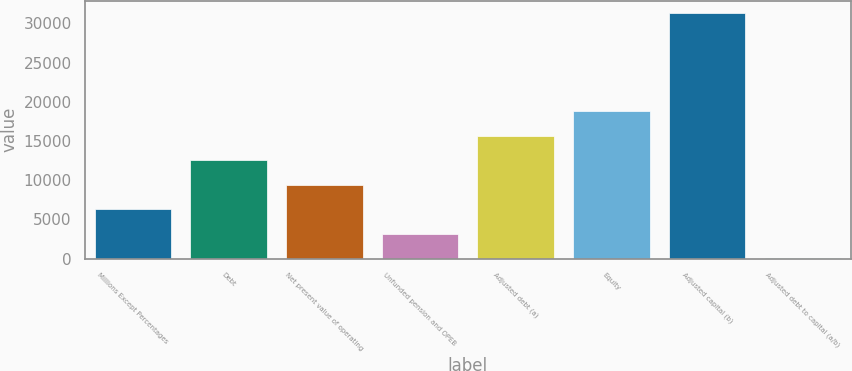<chart> <loc_0><loc_0><loc_500><loc_500><bar_chart><fcel>Millions Except Percentages<fcel>Debt<fcel>Net present value of operating<fcel>Unfunded pension and OPEB<fcel>Adjusted debt (a)<fcel>Equity<fcel>Adjusted capital (b)<fcel>Adjusted debt to capital (a/b)<nl><fcel>6298.76<fcel>12556.8<fcel>9427.79<fcel>3169.73<fcel>15685.9<fcel>18814.9<fcel>31331<fcel>40.7<nl></chart> 